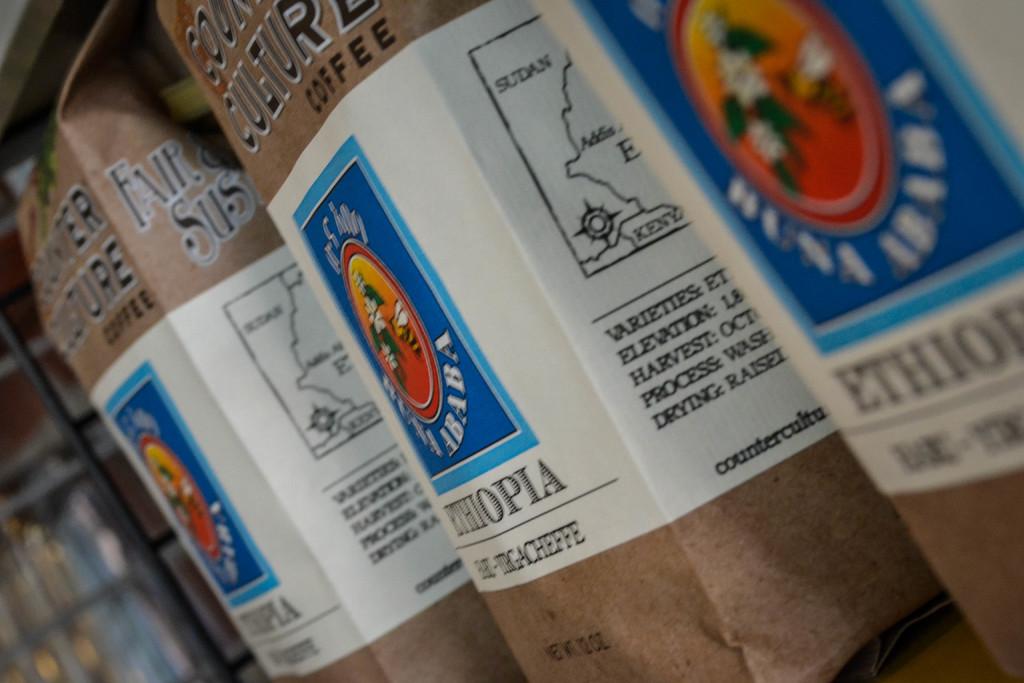What country is this coffee from?
Provide a short and direct response. Ethiopia. 